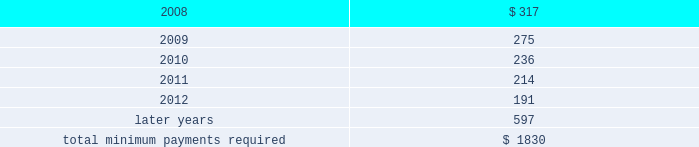Notes to consolidated financial statements at december 31 , 2007 , future minimum rental payments required under operating leases for continuing operations that have initial or remaining noncancelable lease terms in excess of one year , net of sublease rental income , most of which pertain to real estate leases , are as follows : ( millions ) .
Aon corporation .
What portion of the total minimum payments required for lease commitments is due in the upcoming year? 
Computations: (317 / 1830)
Answer: 0.17322. 